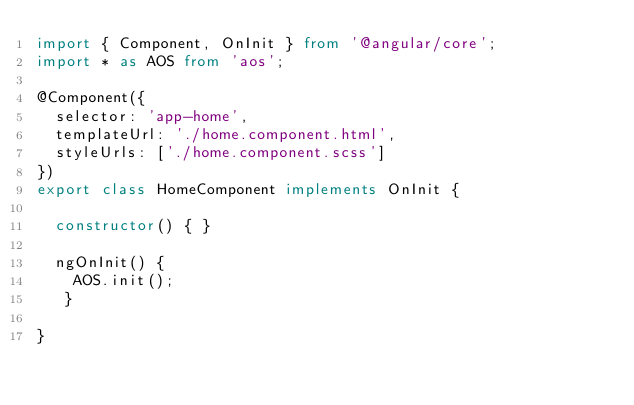<code> <loc_0><loc_0><loc_500><loc_500><_TypeScript_>import { Component, OnInit } from '@angular/core';
import * as AOS from 'aos';

@Component({
  selector: 'app-home',
  templateUrl: './home.component.html',
  styleUrls: ['./home.component.scss']
})
export class HomeComponent implements OnInit {

  constructor() { }

  ngOnInit() {
    AOS.init();
   }

}
</code> 